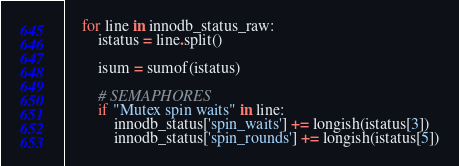<code> <loc_0><loc_0><loc_500><loc_500><_Python_>
	for line in innodb_status_raw:
		istatus = line.split()

		isum = sumof(istatus)

		# SEMAPHORES
		if "Mutex spin waits" in line:
			innodb_status['spin_waits'] += longish(istatus[3])
			innodb_status['spin_rounds'] += longish(istatus[5])</code> 